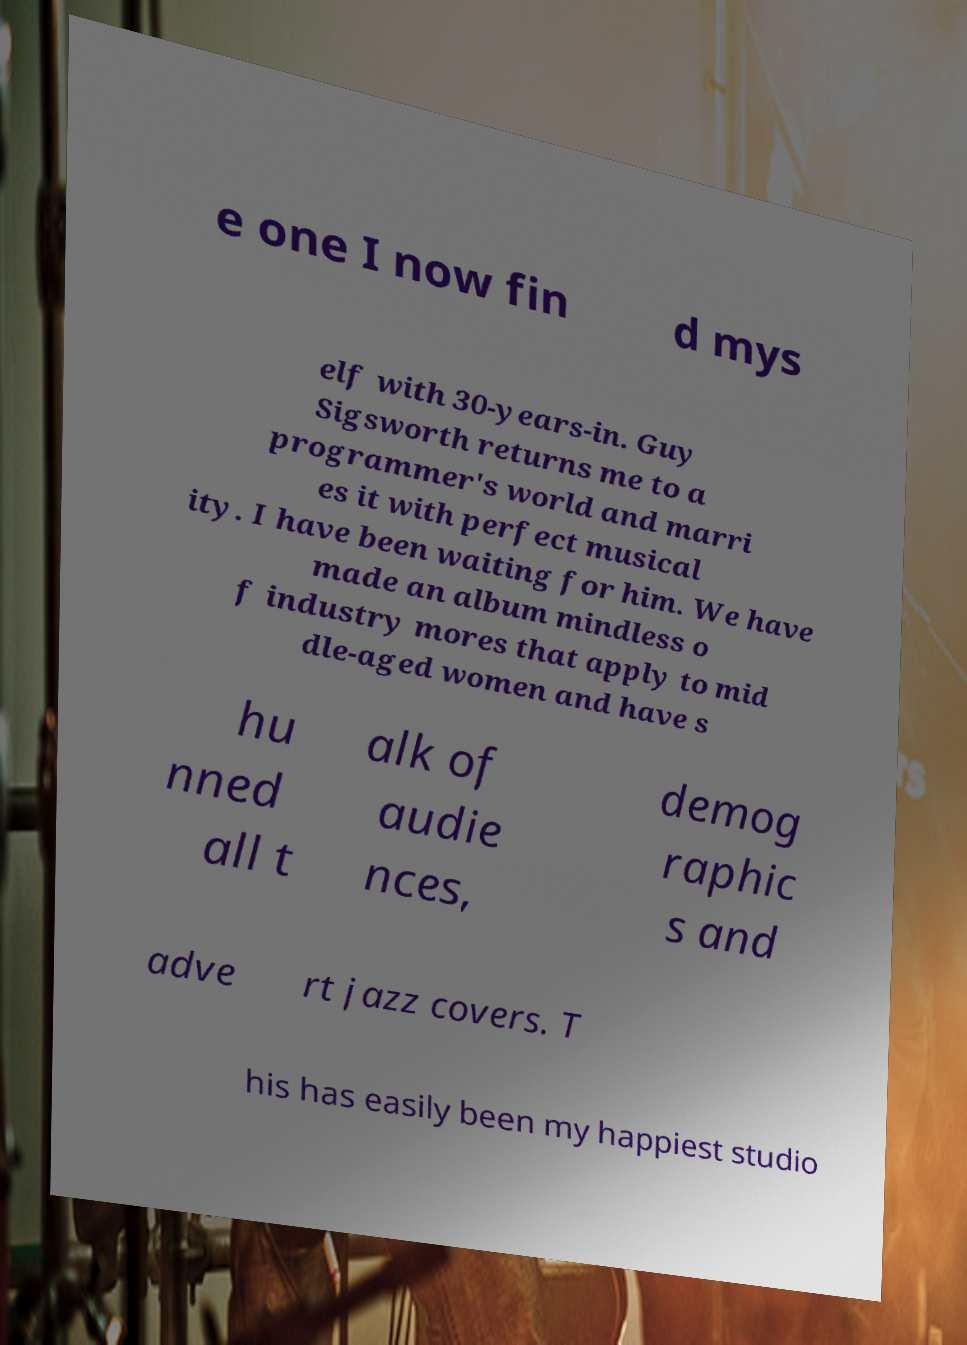For documentation purposes, I need the text within this image transcribed. Could you provide that? e one I now fin d mys elf with 30-years-in. Guy Sigsworth returns me to a programmer's world and marri es it with perfect musical ity. I have been waiting for him. We have made an album mindless o f industry mores that apply to mid dle-aged women and have s hu nned all t alk of audie nces, demog raphic s and adve rt jazz covers. T his has easily been my happiest studio 